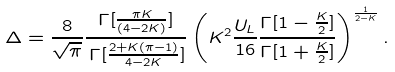Convert formula to latex. <formula><loc_0><loc_0><loc_500><loc_500>\Delta = \frac { 8 } { \sqrt { \pi } } \frac { \Gamma [ \frac { \pi K } { ( 4 - 2 K ) } ] } { \, \Gamma [ \frac { 2 + K ( \pi - 1 ) } { 4 - 2 K } ] } \left ( K ^ { 2 } \frac { U _ { L } } { 1 6 } \frac { \Gamma [ 1 - \frac { K } { 2 } ] } { \Gamma [ 1 + \frac { K } { 2 } ] } \right ) ^ { \frac { 1 } { 2 - K } } .</formula> 